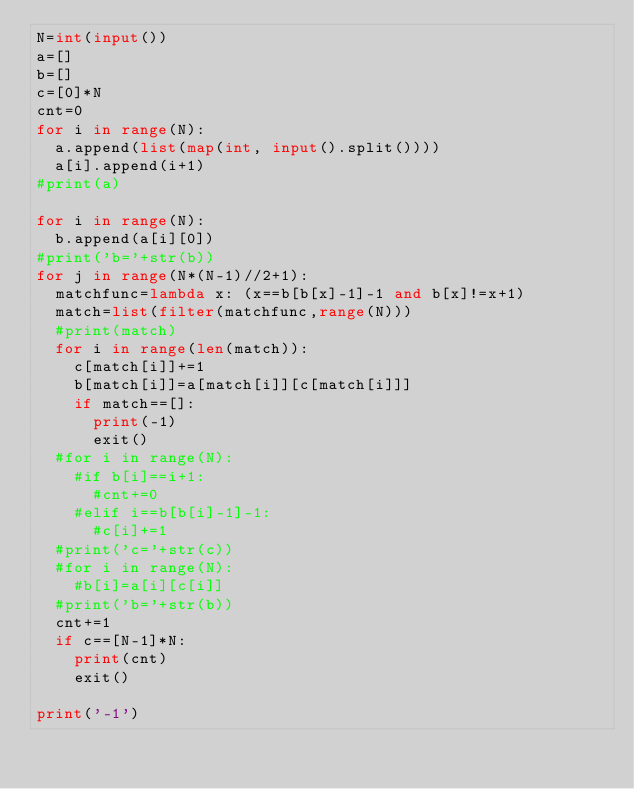<code> <loc_0><loc_0><loc_500><loc_500><_Python_>N=int(input())
a=[]
b=[]
c=[0]*N
cnt=0
for i in range(N):
  a.append(list(map(int, input().split())))
  a[i].append(i+1)
#print(a)

for i in range(N):
  b.append(a[i][0])
#print('b='+str(b))
for j in range(N*(N-1)//2+1):
  matchfunc=lambda x: (x==b[b[x]-1]-1 and b[x]!=x+1)
  match=list(filter(matchfunc,range(N)))
  #print(match)
  for i in range(len(match)):
    c[match[i]]+=1
    b[match[i]]=a[match[i]][c[match[i]]]
    if match==[]:
      print(-1)
      exit()  
  #for i in range(N):
    #if b[i]==i+1:
      #cnt+=0
    #elif i==b[b[i]-1]-1:
      #c[i]+=1
  #print('c='+str(c))
  #for i in range(N):
    #b[i]=a[i][c[i]]
  #print('b='+str(b))
  cnt+=1
  if c==[N-1]*N:
    print(cnt)
    exit()

print('-1')</code> 